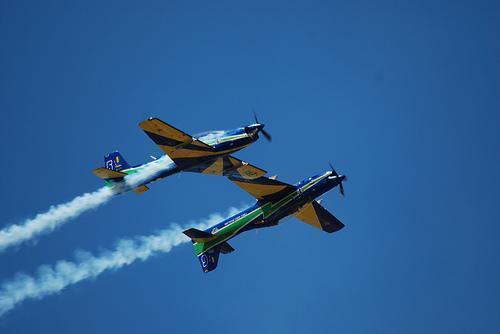How many planes are there?
Give a very brief answer. 2. 